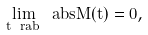Convert formula to latex. <formula><loc_0><loc_0><loc_500><loc_500>\lim _ { t \ r a b } \ a b s { M ( t ) } = 0 ,</formula> 